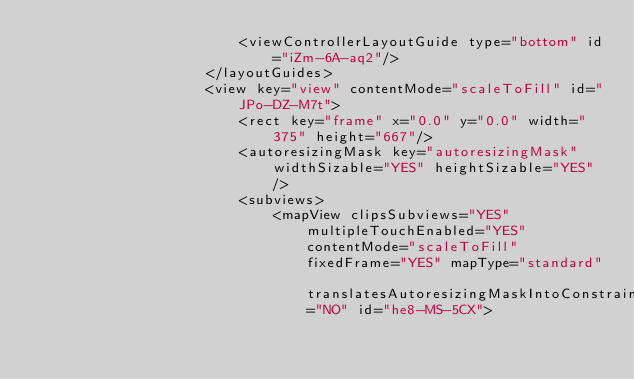<code> <loc_0><loc_0><loc_500><loc_500><_XML_>                        <viewControllerLayoutGuide type="bottom" id="iZm-6A-aq2"/>
                    </layoutGuides>
                    <view key="view" contentMode="scaleToFill" id="JPo-DZ-M7t">
                        <rect key="frame" x="0.0" y="0.0" width="375" height="667"/>
                        <autoresizingMask key="autoresizingMask" widthSizable="YES" heightSizable="YES"/>
                        <subviews>
                            <mapView clipsSubviews="YES" multipleTouchEnabled="YES" contentMode="scaleToFill" fixedFrame="YES" mapType="standard" translatesAutoresizingMaskIntoConstraints="NO" id="he8-MS-5CX"></code> 